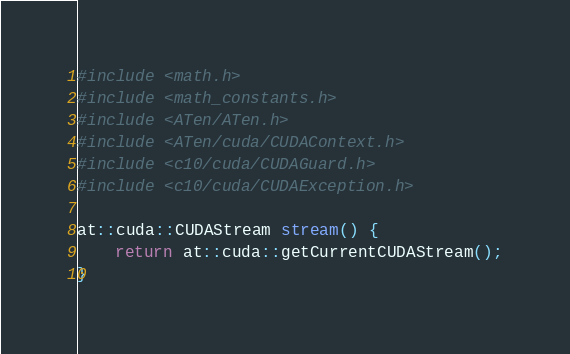<code> <loc_0><loc_0><loc_500><loc_500><_Cuda_>#include <math.h>
#include <math_constants.h>
#include <ATen/ATen.h>
#include <ATen/cuda/CUDAContext.h>
#include <c10/cuda/CUDAGuard.h>
#include <c10/cuda/CUDAException.h>

at::cuda::CUDAStream stream() { 
    return at::cuda::getCurrentCUDAStream();
}</code> 